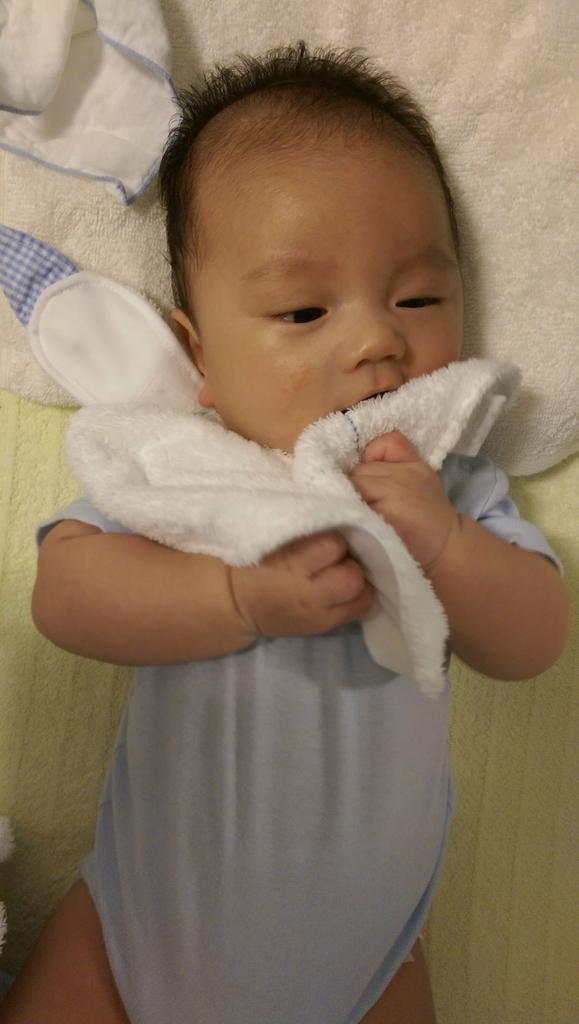What is the main subject of the image? The main subject of the image is a baby. What is the baby doing in the image? The baby is sleeping in the image. What color and pattern is the cloth the baby is lying on? The cloth is cream and white in color. What is the baby wearing in the image? The baby is wearing a blue dress. What is the baby holding in the image? The baby is holding a white cloth. How many sisters does the baby have in the image? There is no mention of sisters in the image, so we cannot determine the number of sisters the baby has. What time does the clock in the image show? There is no clock present in the image, so we cannot determine the time. 